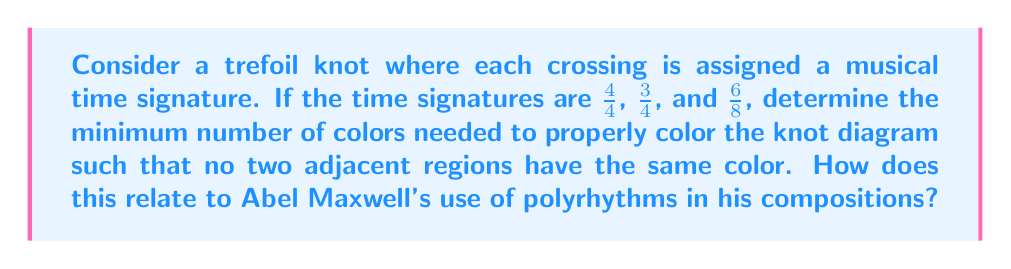Could you help me with this problem? Let's approach this step-by-step:

1) First, we need to understand the concept of knot colorability. A knot diagram is properly colored if each region is assigned a color such that no two adjacent regions share the same color.

2) The trefoil knot divides the plane into four regions. Let's label these regions A, B, C, and D.

3) In knot theory, the minimum number of colors needed to properly color a knot diagram is related to the determinant of the knot. For the trefoil knot, the determinant is 3.

4) However, we need to consider the musical time signatures given:
   - 4/4 (common time)
   - 3/4 (waltz time)
   - 6/8 (compound duple time)

5) These time signatures can be represented as fractions: $\frac{4}{4}$, $\frac{3}{4}$, and $\frac{6}{8}$.

6) To find a common denominator, we can use the least common multiple (LCM) of 4 and 8:
   $LCM(4,8) = 8$

7) Converting all time signatures to eighths:
   - 4/4 = 8/8
   - 3/4 = 6/8
   - 6/8 = 6/8

8) Now we have two distinct values: 8/8 and 6/8. This suggests we need at least two colors to properly color the knot diagram.

9) However, due to the structure of the trefoil knot, we actually need three colors to ensure no adjacent regions have the same color.

10) This aligns with the determinant of the trefoil knot being 3.

11) Relating to Abel Maxwell's music: The use of different time signatures (4/4, 3/4, 6/8) in a single composition is a form of polyrhythm, which Maxwell often employs. Just as the knot requires at least three colors to properly represent these different rhythms, Maxwell's music often layers three or more distinct rhythmic patterns to create complex, interwoven compositions.
Answer: 3 colors 